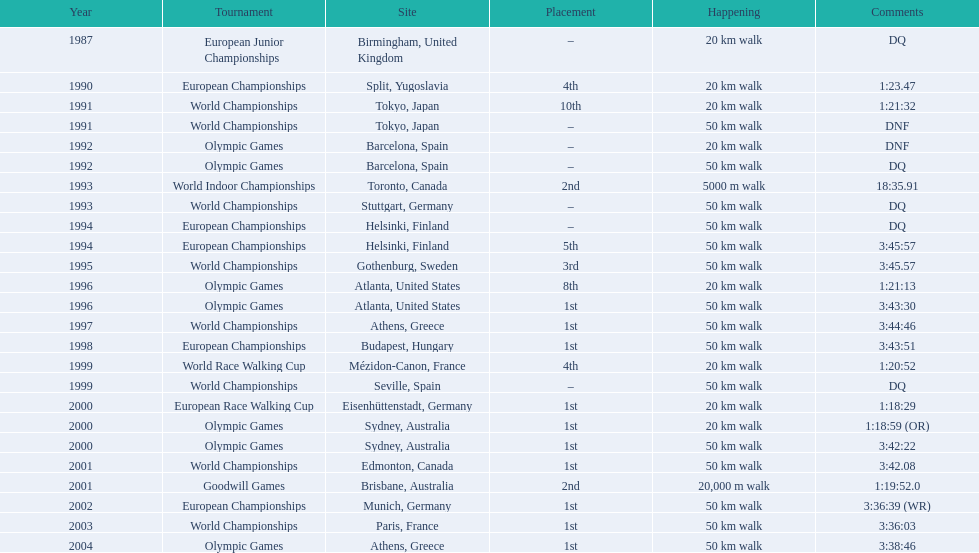Which of the competitions were 50 km walks? World Championships, Olympic Games, World Championships, European Championships, European Championships, World Championships, Olympic Games, World Championships, European Championships, World Championships, Olympic Games, World Championships, European Championships, World Championships, Olympic Games. Of these, which took place during or after the year 2000? Olympic Games, World Championships, European Championships, World Championships, Olympic Games. From these, which took place in athens, greece? Olympic Games. What was the time to finish for this competition? 3:38:46. 